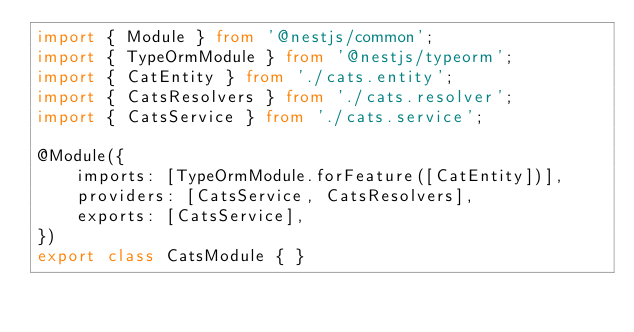Convert code to text. <code><loc_0><loc_0><loc_500><loc_500><_TypeScript_>import { Module } from '@nestjs/common';
import { TypeOrmModule } from '@nestjs/typeorm';
import { CatEntity } from './cats.entity';
import { CatsResolvers } from './cats.resolver';
import { CatsService } from './cats.service';

@Module({
    imports: [TypeOrmModule.forFeature([CatEntity])],
    providers: [CatsService, CatsResolvers],
    exports: [CatsService],
})
export class CatsModule { }
</code> 